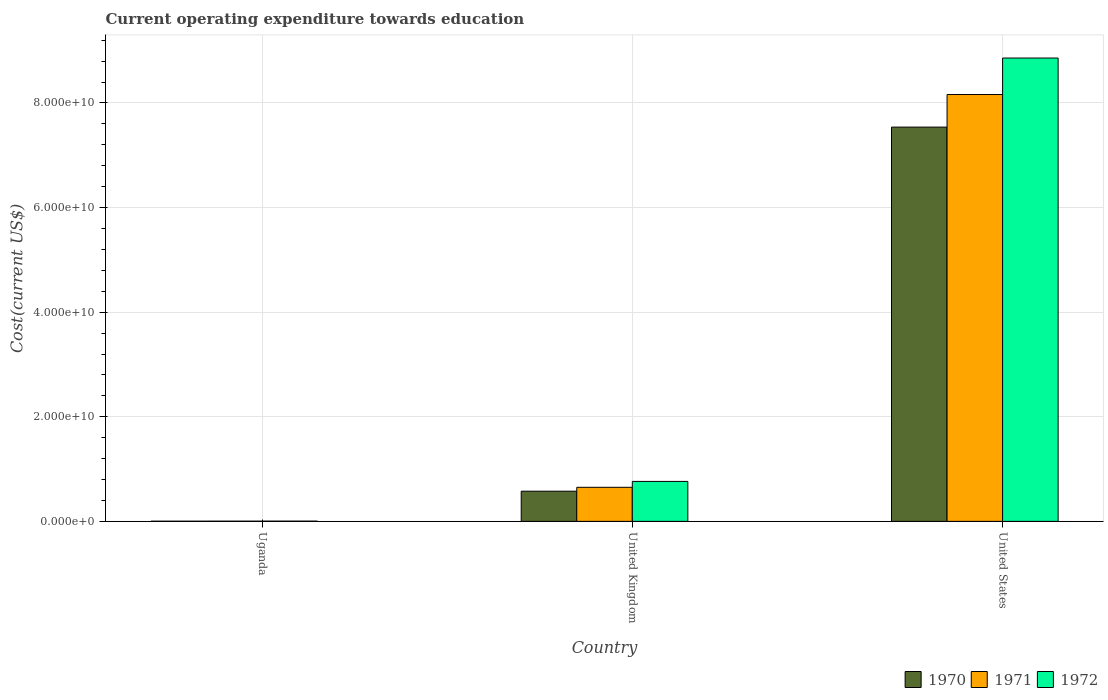How many groups of bars are there?
Make the answer very short. 3. Are the number of bars on each tick of the X-axis equal?
Provide a succinct answer. Yes. How many bars are there on the 3rd tick from the left?
Your answer should be very brief. 3. In how many cases, is the number of bars for a given country not equal to the number of legend labels?
Your answer should be compact. 0. What is the expenditure towards education in 1972 in Uganda?
Your answer should be very brief. 4.35e+07. Across all countries, what is the maximum expenditure towards education in 1970?
Make the answer very short. 7.54e+1. Across all countries, what is the minimum expenditure towards education in 1971?
Provide a short and direct response. 3.77e+07. In which country was the expenditure towards education in 1972 minimum?
Your response must be concise. Uganda. What is the total expenditure towards education in 1971 in the graph?
Provide a succinct answer. 8.82e+1. What is the difference between the expenditure towards education in 1970 in Uganda and that in United States?
Ensure brevity in your answer.  -7.53e+1. What is the difference between the expenditure towards education in 1972 in Uganda and the expenditure towards education in 1970 in United States?
Your answer should be very brief. -7.53e+1. What is the average expenditure towards education in 1971 per country?
Offer a very short reply. 2.94e+1. What is the difference between the expenditure towards education of/in 1970 and expenditure towards education of/in 1971 in United States?
Offer a terse response. -6.23e+09. What is the ratio of the expenditure towards education in 1970 in United Kingdom to that in United States?
Your answer should be compact. 0.08. Is the difference between the expenditure towards education in 1970 in United Kingdom and United States greater than the difference between the expenditure towards education in 1971 in United Kingdom and United States?
Ensure brevity in your answer.  Yes. What is the difference between the highest and the second highest expenditure towards education in 1972?
Offer a very short reply. 8.85e+1. What is the difference between the highest and the lowest expenditure towards education in 1972?
Provide a short and direct response. 8.85e+1. In how many countries, is the expenditure towards education in 1971 greater than the average expenditure towards education in 1971 taken over all countries?
Provide a short and direct response. 1. What does the 3rd bar from the right in Uganda represents?
Your answer should be compact. 1970. How many bars are there?
Your response must be concise. 9. Are the values on the major ticks of Y-axis written in scientific E-notation?
Offer a terse response. Yes. Does the graph contain grids?
Give a very brief answer. Yes. How many legend labels are there?
Make the answer very short. 3. How are the legend labels stacked?
Offer a very short reply. Horizontal. What is the title of the graph?
Your answer should be compact. Current operating expenditure towards education. Does "1998" appear as one of the legend labels in the graph?
Your answer should be very brief. No. What is the label or title of the X-axis?
Offer a very short reply. Country. What is the label or title of the Y-axis?
Keep it short and to the point. Cost(current US$). What is the Cost(current US$) in 1970 in Uganda?
Keep it short and to the point. 3.36e+07. What is the Cost(current US$) in 1971 in Uganda?
Provide a short and direct response. 3.77e+07. What is the Cost(current US$) of 1972 in Uganda?
Give a very brief answer. 4.35e+07. What is the Cost(current US$) in 1970 in United Kingdom?
Keep it short and to the point. 5.77e+09. What is the Cost(current US$) of 1971 in United Kingdom?
Keep it short and to the point. 6.51e+09. What is the Cost(current US$) of 1972 in United Kingdom?
Provide a succinct answer. 7.64e+09. What is the Cost(current US$) in 1970 in United States?
Offer a terse response. 7.54e+1. What is the Cost(current US$) in 1971 in United States?
Provide a short and direct response. 8.16e+1. What is the Cost(current US$) in 1972 in United States?
Provide a short and direct response. 8.86e+1. Across all countries, what is the maximum Cost(current US$) in 1970?
Your answer should be very brief. 7.54e+1. Across all countries, what is the maximum Cost(current US$) of 1971?
Your response must be concise. 8.16e+1. Across all countries, what is the maximum Cost(current US$) of 1972?
Make the answer very short. 8.86e+1. Across all countries, what is the minimum Cost(current US$) of 1970?
Keep it short and to the point. 3.36e+07. Across all countries, what is the minimum Cost(current US$) of 1971?
Offer a terse response. 3.77e+07. Across all countries, what is the minimum Cost(current US$) of 1972?
Keep it short and to the point. 4.35e+07. What is the total Cost(current US$) of 1970 in the graph?
Your answer should be compact. 8.12e+1. What is the total Cost(current US$) of 1971 in the graph?
Offer a very short reply. 8.82e+1. What is the total Cost(current US$) of 1972 in the graph?
Ensure brevity in your answer.  9.63e+1. What is the difference between the Cost(current US$) in 1970 in Uganda and that in United Kingdom?
Ensure brevity in your answer.  -5.74e+09. What is the difference between the Cost(current US$) in 1971 in Uganda and that in United Kingdom?
Provide a short and direct response. -6.48e+09. What is the difference between the Cost(current US$) of 1972 in Uganda and that in United Kingdom?
Provide a succinct answer. -7.60e+09. What is the difference between the Cost(current US$) of 1970 in Uganda and that in United States?
Ensure brevity in your answer.  -7.53e+1. What is the difference between the Cost(current US$) of 1971 in Uganda and that in United States?
Provide a short and direct response. -8.16e+1. What is the difference between the Cost(current US$) of 1972 in Uganda and that in United States?
Your answer should be very brief. -8.85e+1. What is the difference between the Cost(current US$) of 1970 in United Kingdom and that in United States?
Your response must be concise. -6.96e+1. What is the difference between the Cost(current US$) in 1971 in United Kingdom and that in United States?
Offer a terse response. -7.51e+1. What is the difference between the Cost(current US$) in 1972 in United Kingdom and that in United States?
Your answer should be very brief. -8.09e+1. What is the difference between the Cost(current US$) of 1970 in Uganda and the Cost(current US$) of 1971 in United Kingdom?
Offer a terse response. -6.48e+09. What is the difference between the Cost(current US$) of 1970 in Uganda and the Cost(current US$) of 1972 in United Kingdom?
Ensure brevity in your answer.  -7.61e+09. What is the difference between the Cost(current US$) of 1971 in Uganda and the Cost(current US$) of 1972 in United Kingdom?
Give a very brief answer. -7.60e+09. What is the difference between the Cost(current US$) of 1970 in Uganda and the Cost(current US$) of 1971 in United States?
Give a very brief answer. -8.16e+1. What is the difference between the Cost(current US$) in 1970 in Uganda and the Cost(current US$) in 1972 in United States?
Offer a terse response. -8.86e+1. What is the difference between the Cost(current US$) in 1971 in Uganda and the Cost(current US$) in 1972 in United States?
Your response must be concise. -8.86e+1. What is the difference between the Cost(current US$) in 1970 in United Kingdom and the Cost(current US$) in 1971 in United States?
Ensure brevity in your answer.  -7.58e+1. What is the difference between the Cost(current US$) in 1970 in United Kingdom and the Cost(current US$) in 1972 in United States?
Your answer should be very brief. -8.28e+1. What is the difference between the Cost(current US$) in 1971 in United Kingdom and the Cost(current US$) in 1972 in United States?
Provide a succinct answer. -8.21e+1. What is the average Cost(current US$) in 1970 per country?
Your answer should be compact. 2.71e+1. What is the average Cost(current US$) of 1971 per country?
Offer a very short reply. 2.94e+1. What is the average Cost(current US$) of 1972 per country?
Provide a succinct answer. 3.21e+1. What is the difference between the Cost(current US$) of 1970 and Cost(current US$) of 1971 in Uganda?
Offer a very short reply. -4.06e+06. What is the difference between the Cost(current US$) of 1970 and Cost(current US$) of 1972 in Uganda?
Provide a short and direct response. -9.89e+06. What is the difference between the Cost(current US$) in 1971 and Cost(current US$) in 1972 in Uganda?
Your response must be concise. -5.83e+06. What is the difference between the Cost(current US$) in 1970 and Cost(current US$) in 1971 in United Kingdom?
Offer a very short reply. -7.43e+08. What is the difference between the Cost(current US$) of 1970 and Cost(current US$) of 1972 in United Kingdom?
Your answer should be very brief. -1.87e+09. What is the difference between the Cost(current US$) of 1971 and Cost(current US$) of 1972 in United Kingdom?
Make the answer very short. -1.13e+09. What is the difference between the Cost(current US$) in 1970 and Cost(current US$) in 1971 in United States?
Make the answer very short. -6.23e+09. What is the difference between the Cost(current US$) of 1970 and Cost(current US$) of 1972 in United States?
Your answer should be very brief. -1.32e+1. What is the difference between the Cost(current US$) in 1971 and Cost(current US$) in 1972 in United States?
Ensure brevity in your answer.  -6.98e+09. What is the ratio of the Cost(current US$) of 1970 in Uganda to that in United Kingdom?
Your answer should be compact. 0.01. What is the ratio of the Cost(current US$) of 1971 in Uganda to that in United Kingdom?
Your answer should be compact. 0.01. What is the ratio of the Cost(current US$) of 1972 in Uganda to that in United Kingdom?
Ensure brevity in your answer.  0.01. What is the ratio of the Cost(current US$) in 1971 in Uganda to that in United States?
Give a very brief answer. 0. What is the ratio of the Cost(current US$) of 1970 in United Kingdom to that in United States?
Your response must be concise. 0.08. What is the ratio of the Cost(current US$) of 1971 in United Kingdom to that in United States?
Ensure brevity in your answer.  0.08. What is the ratio of the Cost(current US$) of 1972 in United Kingdom to that in United States?
Make the answer very short. 0.09. What is the difference between the highest and the second highest Cost(current US$) of 1970?
Provide a succinct answer. 6.96e+1. What is the difference between the highest and the second highest Cost(current US$) of 1971?
Give a very brief answer. 7.51e+1. What is the difference between the highest and the second highest Cost(current US$) in 1972?
Offer a very short reply. 8.09e+1. What is the difference between the highest and the lowest Cost(current US$) of 1970?
Your response must be concise. 7.53e+1. What is the difference between the highest and the lowest Cost(current US$) in 1971?
Offer a very short reply. 8.16e+1. What is the difference between the highest and the lowest Cost(current US$) in 1972?
Offer a very short reply. 8.85e+1. 